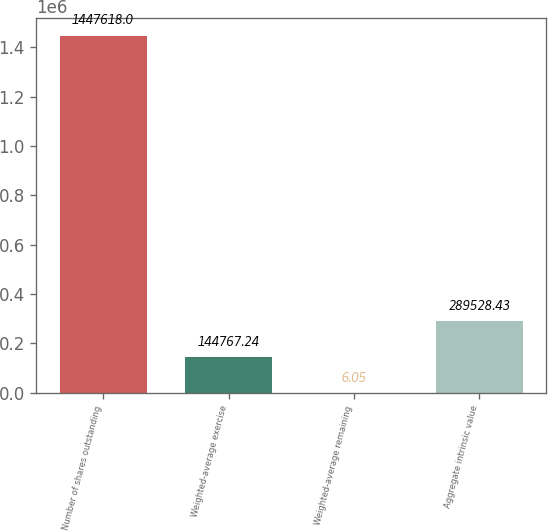<chart> <loc_0><loc_0><loc_500><loc_500><bar_chart><fcel>Number of shares outstanding<fcel>Weighted-average exercise<fcel>Weighted-average remaining<fcel>Aggregate intrinsic value<nl><fcel>1.44762e+06<fcel>144767<fcel>6.05<fcel>289528<nl></chart> 